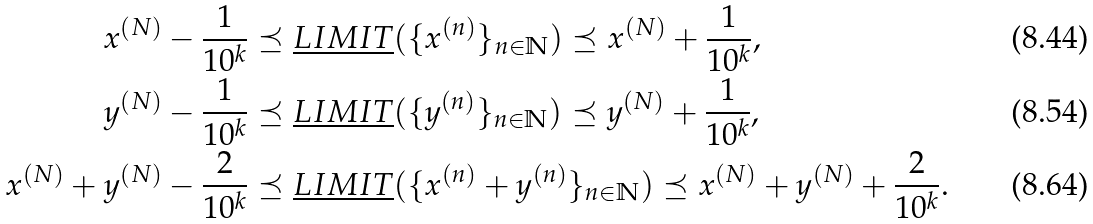Convert formula to latex. <formula><loc_0><loc_0><loc_500><loc_500>x ^ { ( N ) } - \frac { 1 } { 1 0 ^ { k } } & \preceq \underline { L I M I T } ( \{ x ^ { ( n ) } \} _ { n \in \mathbb { N } } ) \preceq x ^ { ( N ) } + \frac { 1 } { 1 0 ^ { k } } , \\ y ^ { ( N ) } - \frac { 1 } { 1 0 ^ { k } } & \preceq \underline { L I M I T } ( \{ y ^ { ( n ) } \} _ { n \in \mathbb { N } } ) \preceq y ^ { ( N ) } + \frac { 1 } { 1 0 ^ { k } } , \\ x ^ { ( N ) } + y ^ { ( N ) } - \frac { 2 } { 1 0 ^ { k } } & \preceq \underline { L I M I T } ( \{ x ^ { ( n ) } + y ^ { ( n ) } \} _ { n \in \mathbb { N } } ) \preceq x ^ { ( N ) } + y ^ { ( N ) } + \frac { 2 } { 1 0 ^ { k } } .</formula> 